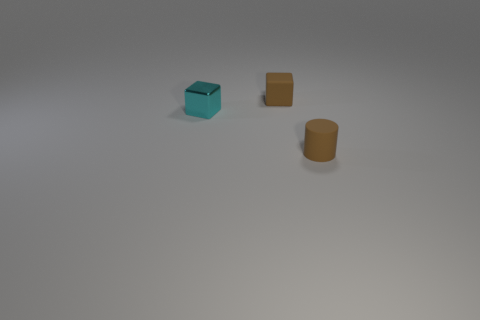Can you tell me the shapes of the objects shown in the image? Certainly! The image showcases three distinct shapes: the object on the left is a cube with a visible cavity on one side, giving it an overall box-like appearance. The object in the middle is a solid, rectangular cuboid. The object on the right presents as a cylindrical shape with an open top. 